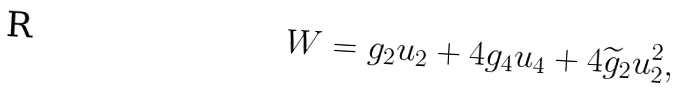Convert formula to latex. <formula><loc_0><loc_0><loc_500><loc_500>W = g _ { 2 } u _ { 2 } + 4 g _ { 4 } u _ { 4 } + 4 \widetilde { g } _ { 2 } u _ { 2 } ^ { 2 } ,</formula> 